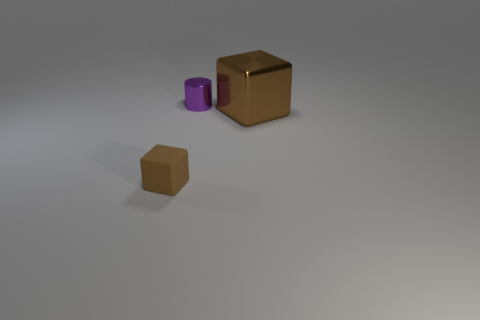What is the tiny cube made of?
Provide a succinct answer. Rubber. What material is the block that is on the right side of the tiny thing behind the brown object that is on the right side of the rubber cube made of?
Offer a terse response. Metal. Is there anything else that has the same material as the tiny brown thing?
Give a very brief answer. No. Do the purple thing and the brown thing on the left side of the small purple shiny cylinder have the same size?
Offer a very short reply. Yes. How many objects are either tiny objects that are to the left of the tiny purple cylinder or blocks that are to the right of the small purple shiny thing?
Offer a very short reply. 2. What is the color of the cube to the right of the small purple object?
Your response must be concise. Brown. Is there a brown metal thing that is in front of the thing that is left of the small shiny cylinder?
Make the answer very short. No. Is the number of large blocks less than the number of tiny things?
Your answer should be compact. Yes. What material is the small thing that is to the left of the small thing behind the large brown block?
Provide a short and direct response. Rubber. Is the size of the metallic cylinder the same as the brown matte block?
Your answer should be compact. Yes. 